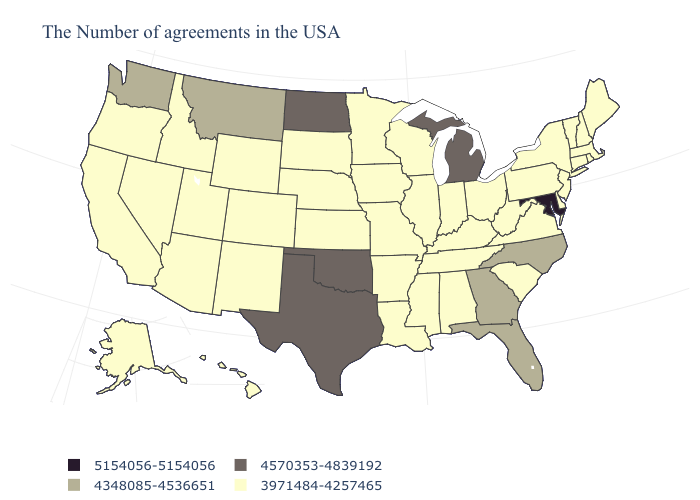Name the states that have a value in the range 5154056-5154056?
Quick response, please. Maryland. Which states hav the highest value in the South?
Write a very short answer. Maryland. Among the states that border New Jersey , which have the highest value?
Short answer required. New York, Delaware, Pennsylvania. Name the states that have a value in the range 5154056-5154056?
Short answer required. Maryland. Is the legend a continuous bar?
Short answer required. No. Which states hav the highest value in the South?
Keep it brief. Maryland. Name the states that have a value in the range 4348085-4536651?
Quick response, please. North Carolina, Florida, Georgia, Montana, Washington. What is the value of Oklahoma?
Write a very short answer. 4570353-4839192. What is the value of Arkansas?
Write a very short answer. 3971484-4257465. What is the highest value in states that border North Dakota?
Concise answer only. 4348085-4536651. What is the value of Ohio?
Be succinct. 3971484-4257465. Among the states that border Arkansas , which have the lowest value?
Quick response, please. Tennessee, Mississippi, Louisiana, Missouri. Among the states that border New Hampshire , which have the lowest value?
Be succinct. Maine, Massachusetts, Vermont. 